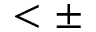<formula> <loc_0><loc_0><loc_500><loc_500>< \pm</formula> 